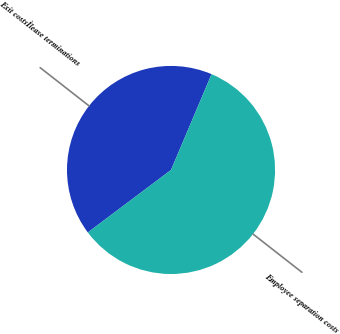<chart> <loc_0><loc_0><loc_500><loc_500><pie_chart><fcel>Exit costsÌlease terminations<fcel>Employee separation costs<nl><fcel>41.62%<fcel>58.38%<nl></chart> 